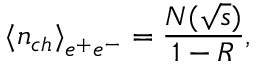Convert formula to latex. <formula><loc_0><loc_0><loc_500><loc_500>{ \langle n _ { c h } \rangle } _ { e ^ { + } e ^ { - } } = \frac { N ( \sqrt { s } ) } { 1 - R } ,</formula> 